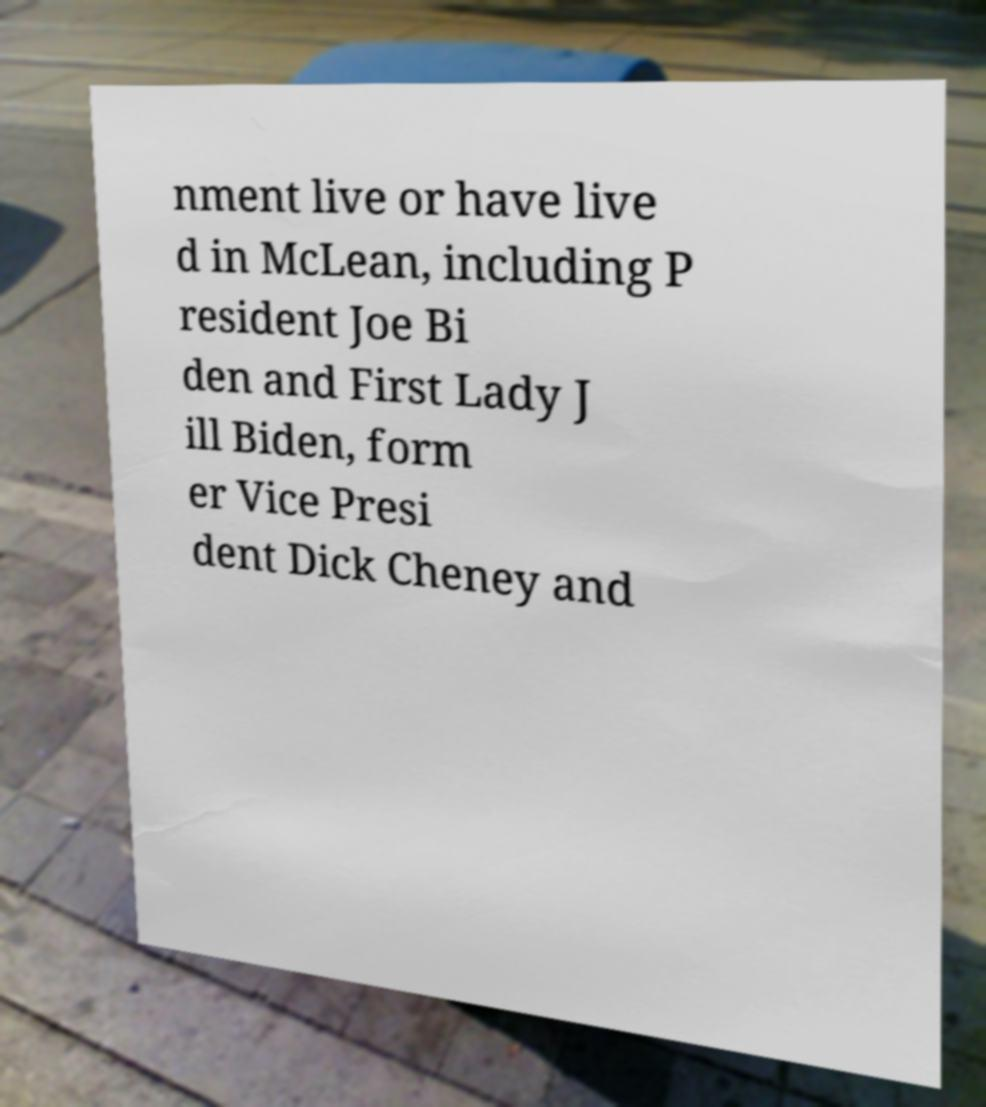Can you accurately transcribe the text from the provided image for me? nment live or have live d in McLean, including P resident Joe Bi den and First Lady J ill Biden, form er Vice Presi dent Dick Cheney and 